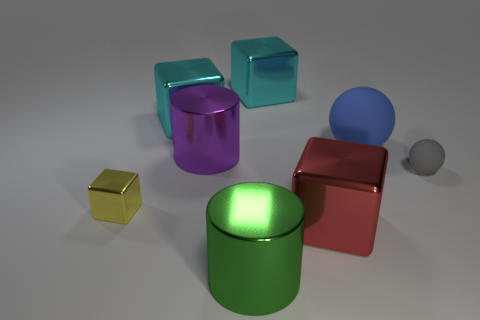Subtract all blue cubes. Subtract all yellow cylinders. How many cubes are left? 4 Add 2 big cyan cubes. How many objects exist? 10 Subtract all cylinders. How many objects are left? 6 Subtract 0 gray cylinders. How many objects are left? 8 Subtract all green objects. Subtract all big red metal things. How many objects are left? 6 Add 5 large blue things. How many large blue things are left? 6 Add 6 tiny purple cylinders. How many tiny purple cylinders exist? 6 